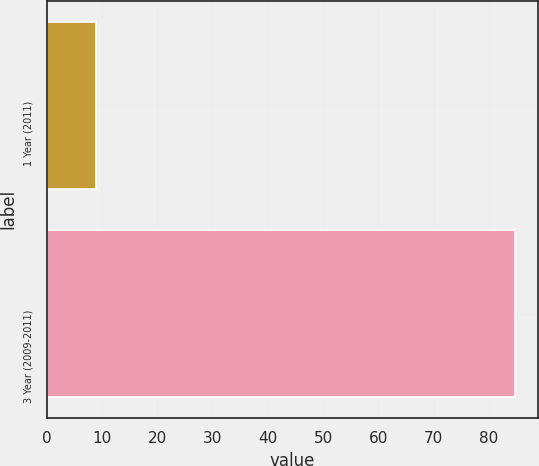<chart> <loc_0><loc_0><loc_500><loc_500><bar_chart><fcel>1 Year (2011)<fcel>3 Year (2009-2011)<nl><fcel>9<fcel>84.7<nl></chart> 